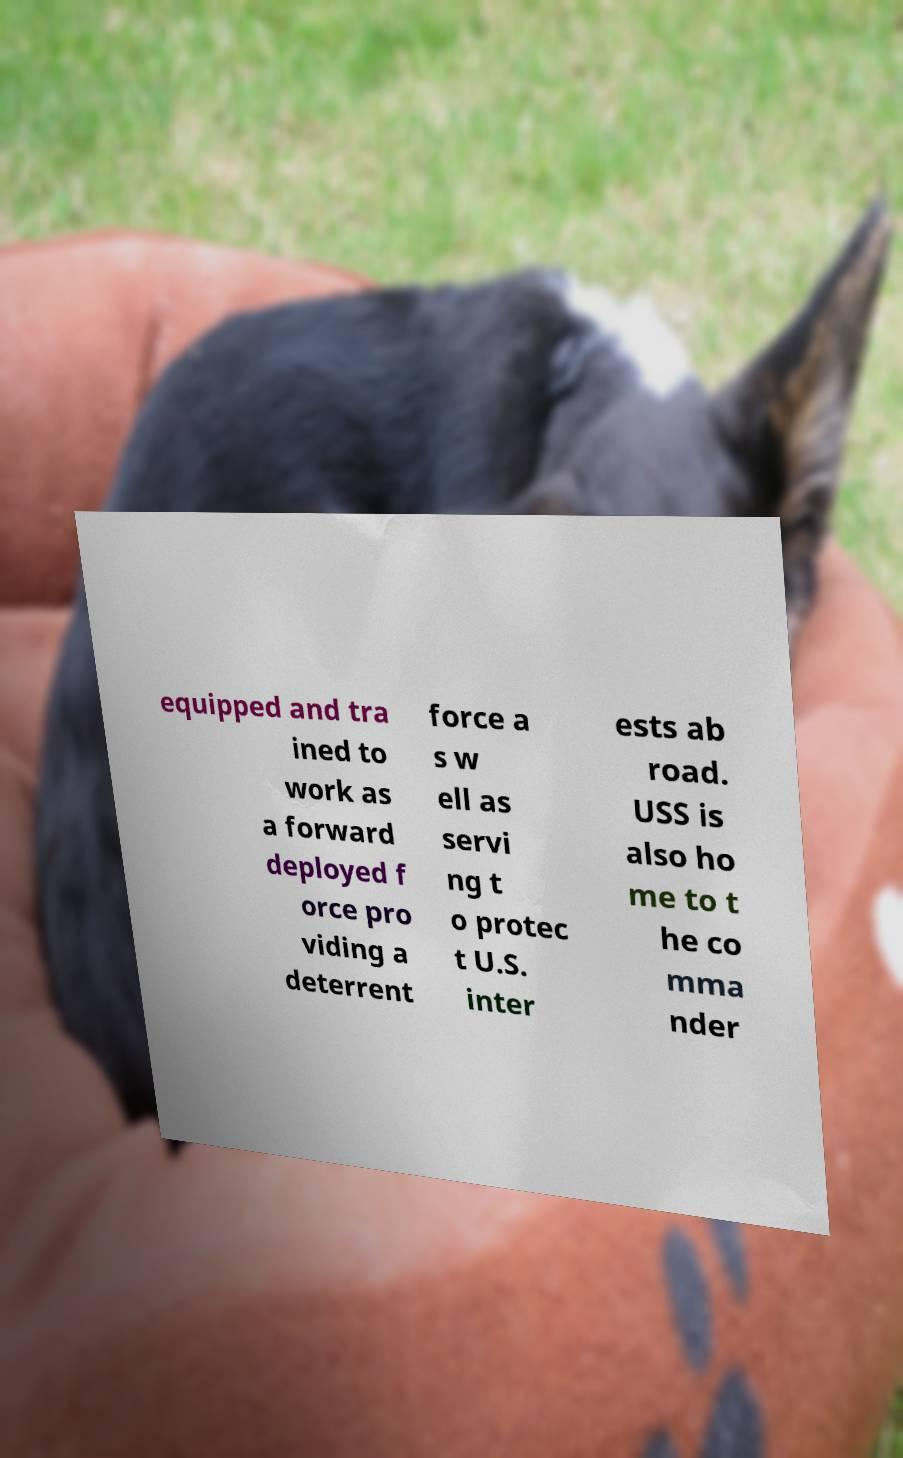Could you assist in decoding the text presented in this image and type it out clearly? equipped and tra ined to work as a forward deployed f orce pro viding a deterrent force a s w ell as servi ng t o protec t U.S. inter ests ab road. USS is also ho me to t he co mma nder 